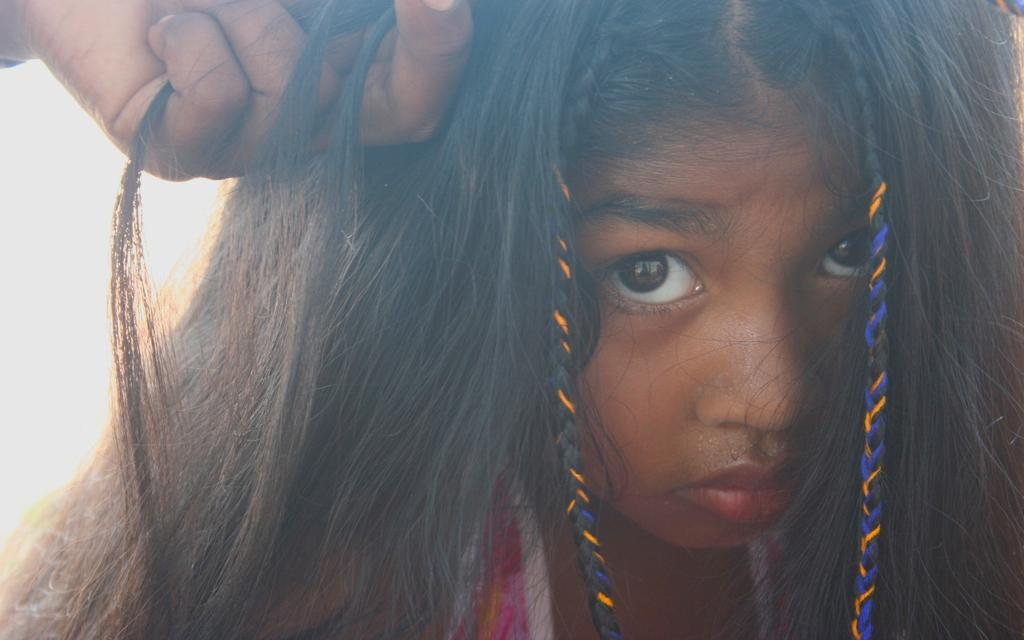Who is the main subject in the image? There is a girl in the image. What is the girl doing in the image? The girl is watching something. Can you describe any interaction between the girl and another person in the image? A person's hand is holding the girl's hair at the top of the image. What type of lace can be seen on the girl's dress in the image? There is no mention of lace or a dress in the image; the girl's clothing is not described. 